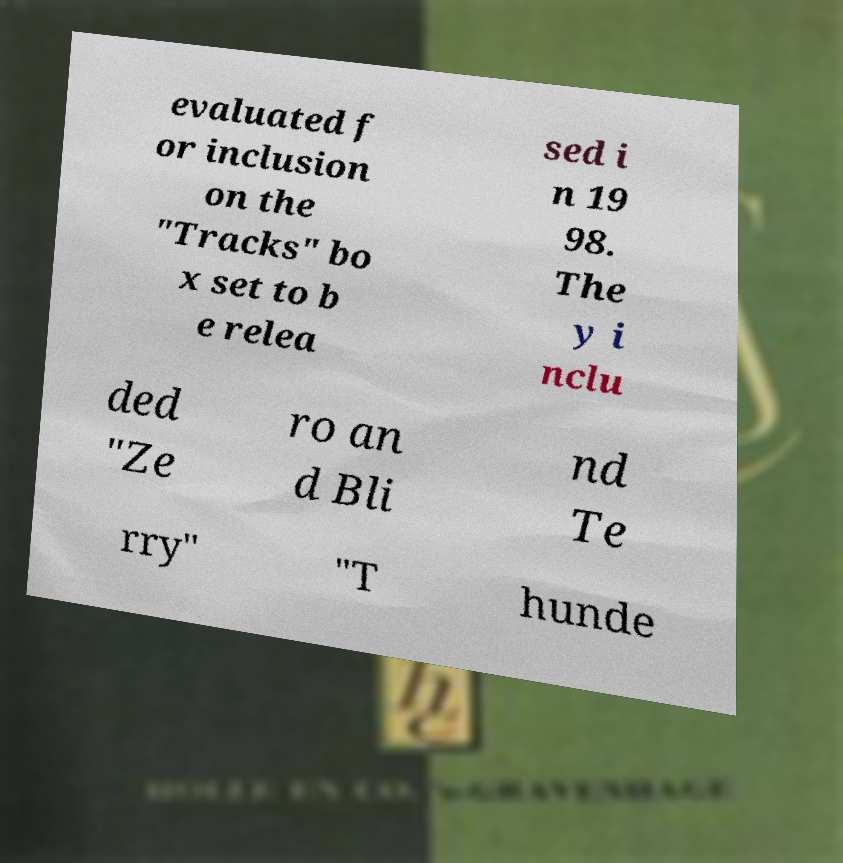For documentation purposes, I need the text within this image transcribed. Could you provide that? evaluated f or inclusion on the "Tracks" bo x set to b e relea sed i n 19 98. The y i nclu ded "Ze ro an d Bli nd Te rry" "T hunde 